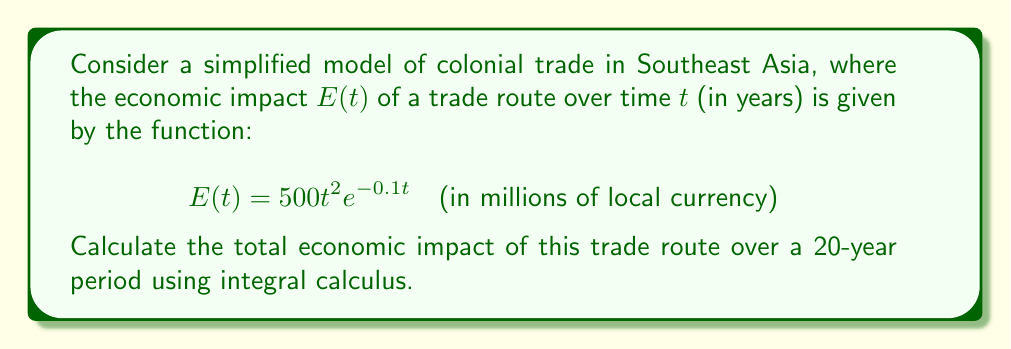Solve this math problem. To calculate the total economic impact over a 20-year period, we need to integrate the function $E(t)$ from $t=0$ to $t=20$. This represents the area under the curve of $E(t)$ over the given time interval.

The integral we need to evaluate is:

$$\int_0^{20} 500t^2e^{-0.1t} dt$$

This integral doesn't have an elementary antiderivative, so we'll need to use integration by parts twice.

Let $u = t^2$ and $dv = e^{-0.1t}dt$

Then $du = 2t dt$ and $v = -10e^{-0.1t}$

Applying integration by parts:

$$\int t^2e^{-0.1t} dt = -10t^2e^{-0.1t} + \int 20te^{-0.1t} dt$$

Now we need to integrate $\int 20te^{-0.1t} dt$

Let $u = t$ and $dv = e^{-0.1t}dt$

Then $du = dt$ and $v = -10e^{-0.1t}$

Applying integration by parts again:

$$\int 20te^{-0.1t} dt = -200te^{-0.1t} + \int 200e^{-0.1t} dt$$

The last integral is straightforward:

$$\int 200e^{-0.1t} dt = -2000e^{-0.1t} + C$$

Putting it all together:

$$\int t^2e^{-0.1t} dt = -10t^2e^{-0.1t} - 200te^{-0.1t} - 2000e^{-0.1t} + C$$

Now we can evaluate this from 0 to 20:

$$[-10t^2e^{-0.1t} - 200te^{-0.1t} - 2000e^{-0.1t}]_0^{20}$$

$$= (-10(20)^2e^{-2} - 200(20)e^{-2} - 2000e^{-2}) - (-10(0)^2e^{0} - 200(0)e^{0} - 2000e^{0})$$

$$= (-4000e^{-2} - 4000e^{-2} - 2000e^{-2}) - (-2000)$$

$$= (-10000e^{-2}) - (-2000)$$

$$= -10000/e^2 + 2000$$

Multiplying by 500 to account for the coefficient in the original function:

$$500(-10000/e^2 + 2000) \approx 811,388.18$$
Answer: The total economic impact over the 20-year period is approximately 811,388.18 million units of local currency. 